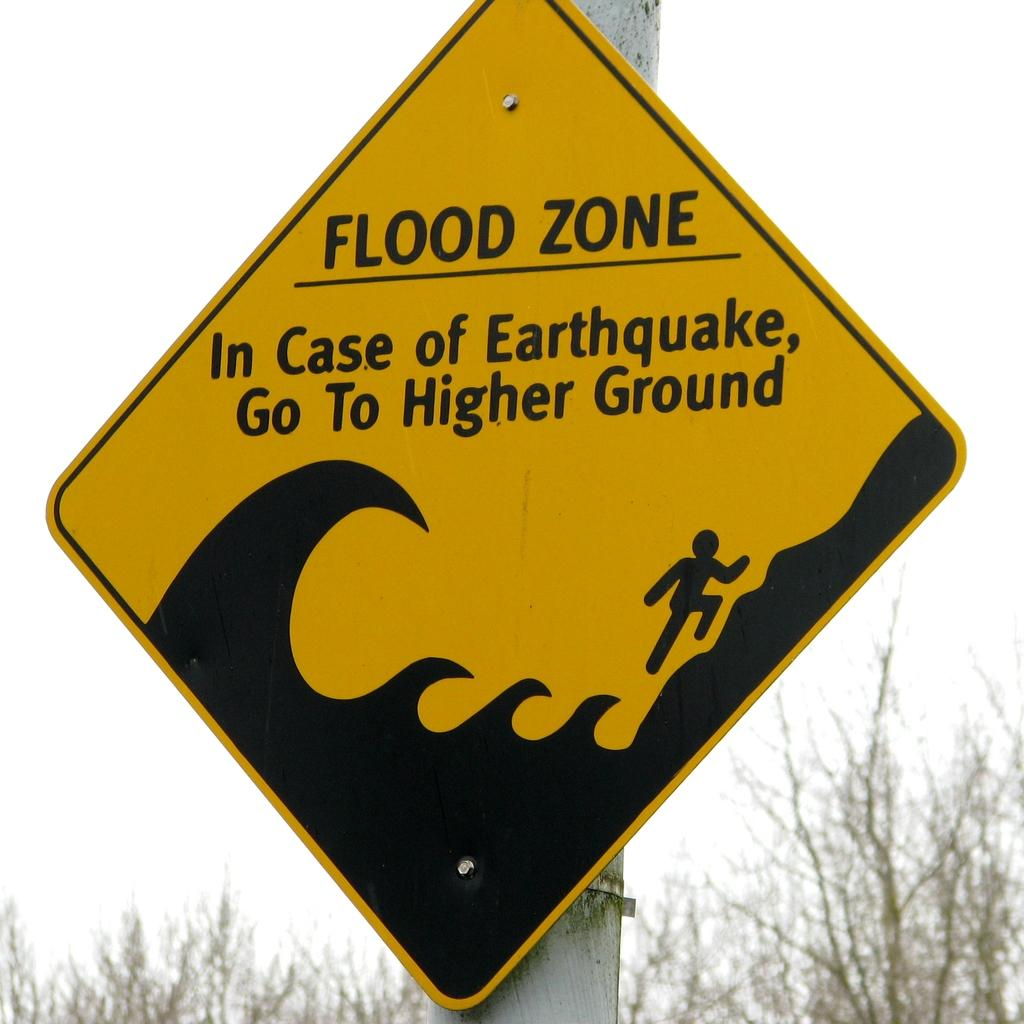<image>
Write a terse but informative summary of the picture. A sign warns people they are in a flood zone and need to get to higher ground if there is an earthquake. 